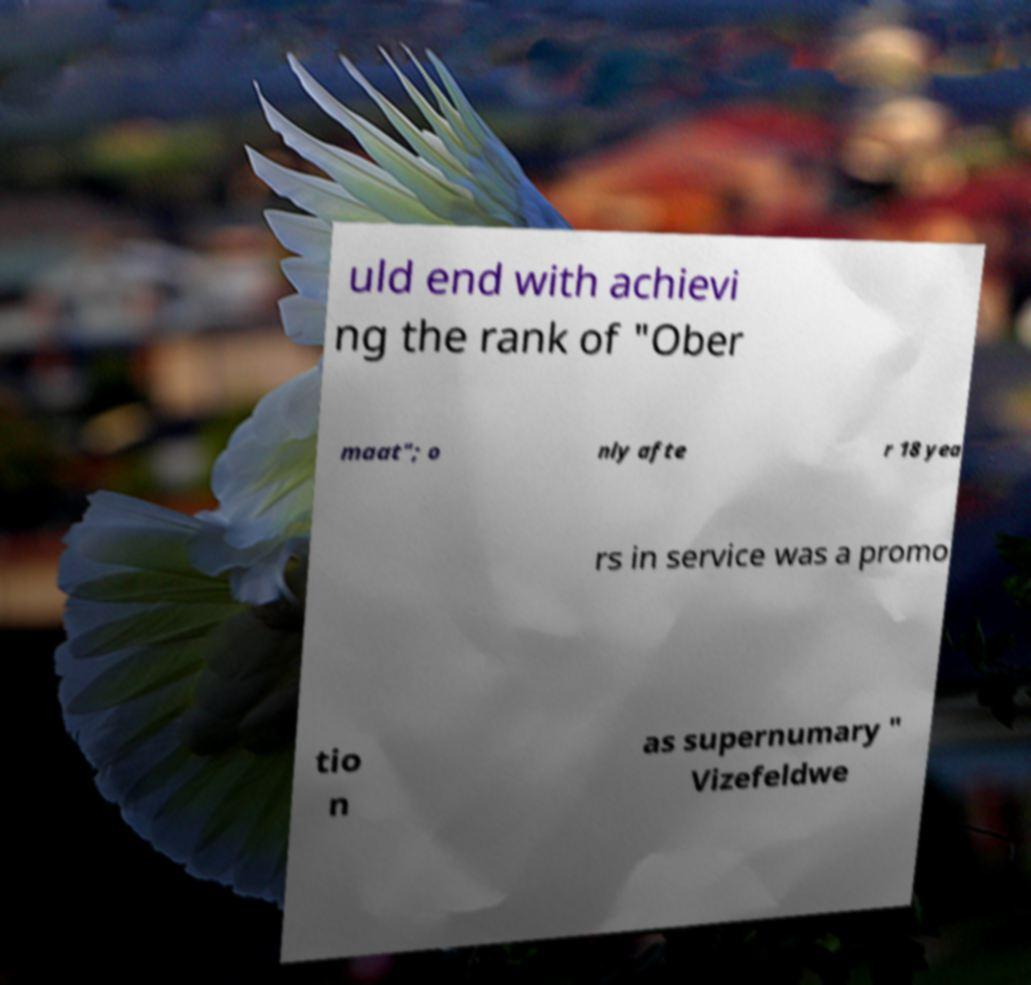What messages or text are displayed in this image? I need them in a readable, typed format. uld end with achievi ng the rank of "Ober maat"; o nly afte r 18 yea rs in service was a promo tio n as supernumary " Vizefeldwe 